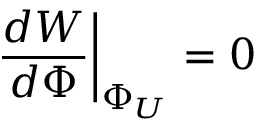Convert formula to latex. <formula><loc_0><loc_0><loc_500><loc_500>{ \frac { d W } { d \Phi } } \Big | _ { \Phi _ { U } } = 0</formula> 